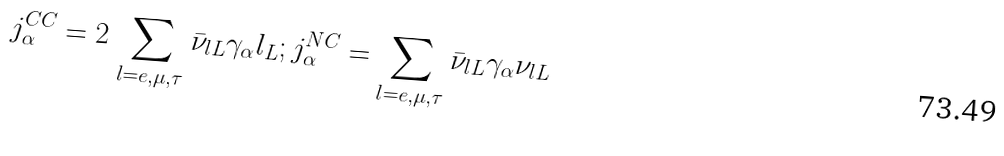<formula> <loc_0><loc_0><loc_500><loc_500>j ^ { C C } _ { \alpha } = 2 \, \sum _ { l = e , \mu , \tau } \bar { \nu } _ { l L } \gamma _ { \alpha } l _ { L } ; j ^ { N C } _ { \alpha } = \sum _ { l = e , \mu , \tau } \bar { \nu } _ { l L } \gamma _ { \alpha } \nu _ { l L }</formula> 